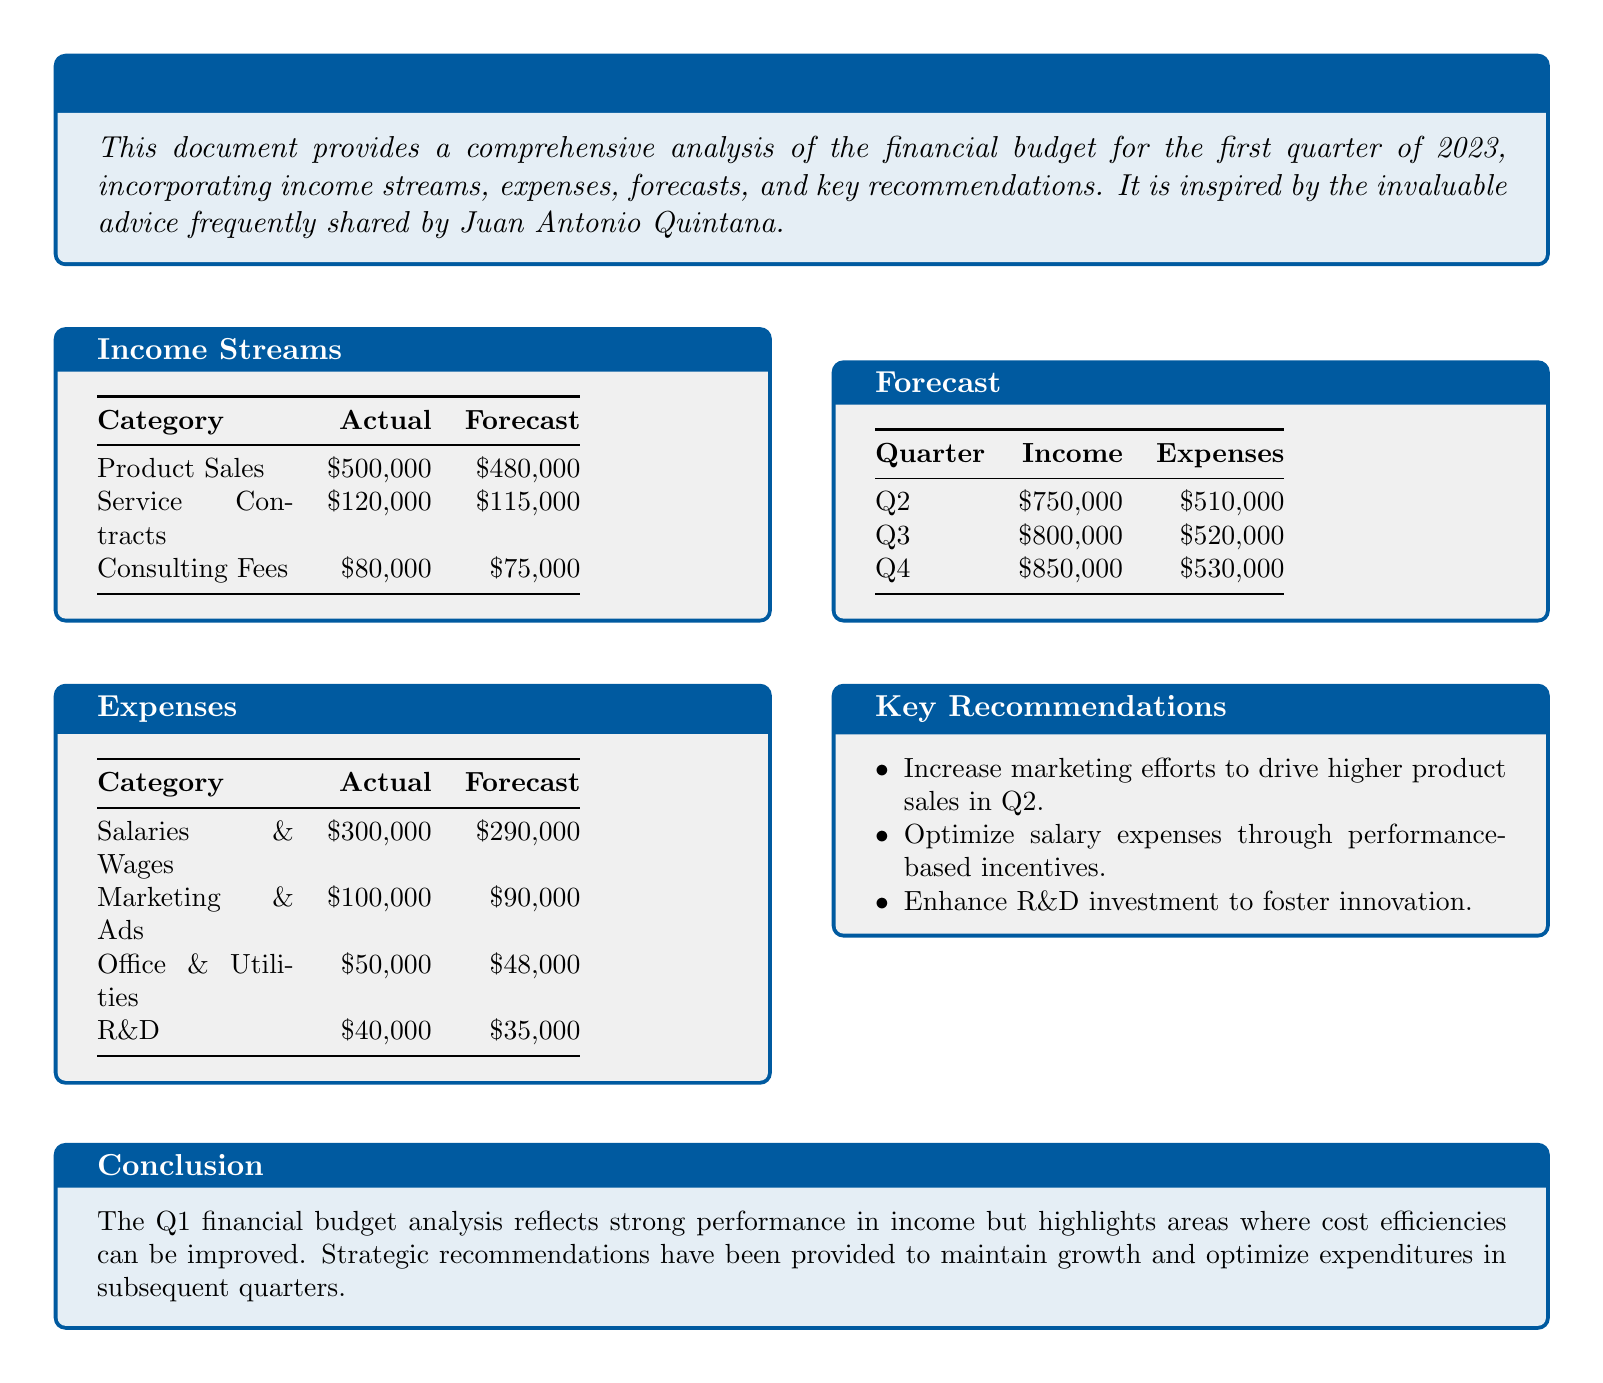What is the total actual income for Q1? The total actual income is the sum of all income streams in Q1: $500,000 + $120,000 + $80,000.
Answer: $700,000 What was the actual expense for R&D in Q1? The actual expense for R&D is listed under expenses in the document.
Answer: $40,000 What is the forecast for product sales in Q2? The forecast for product sales is specifically listed under income forecasts for Q2.
Answer: $750,000 What is the primary recommendation regarding marketing? The document suggests increasing marketing efforts to drive higher product sales in Q2.
Answer: Increase marketing efforts What were the total actual expenses for Q1? The total actual expenses are the sum of all expense categories in Q1: $300,000 + $100,000 + $50,000 + $40,000.
Answer: $490,000 How much higher is the actual income than the forecast for service contracts? To compare, subtract the actual figure from the forecast: $120,000 (actual) - $115,000 (forecast).
Answer: $5,000 What is the expected income for Q4? The expected income for Q4 is clearly outlined in the forecasts section of the document.
Answer: $850,000 In what category is the largest actual expense in Q1? The largest actual expense is directly referenced in the expenses section of the document.
Answer: Salaries & Wages 